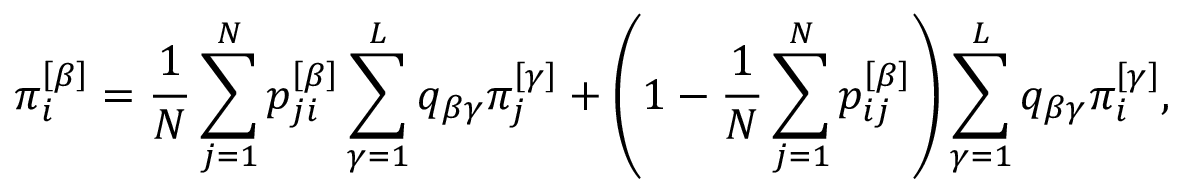Convert formula to latex. <formula><loc_0><loc_0><loc_500><loc_500>\pi _ { i } ^ { \left [ \beta \right ] } = \frac { 1 } { N } \sum _ { j = 1 } ^ { N } p _ { j i } ^ { \left [ \beta \right ] } \sum _ { \gamma = 1 } ^ { L } q _ { \beta \gamma } \pi _ { j } ^ { \left [ \gamma \right ] } + \left ( 1 - \frac { 1 } { N } \sum _ { j = 1 } ^ { N } p _ { i j } ^ { \left [ \beta \right ] } \right ) \sum _ { \gamma = 1 } ^ { L } q _ { \beta \gamma } \pi _ { i } ^ { \left [ \gamma \right ] } ,</formula> 